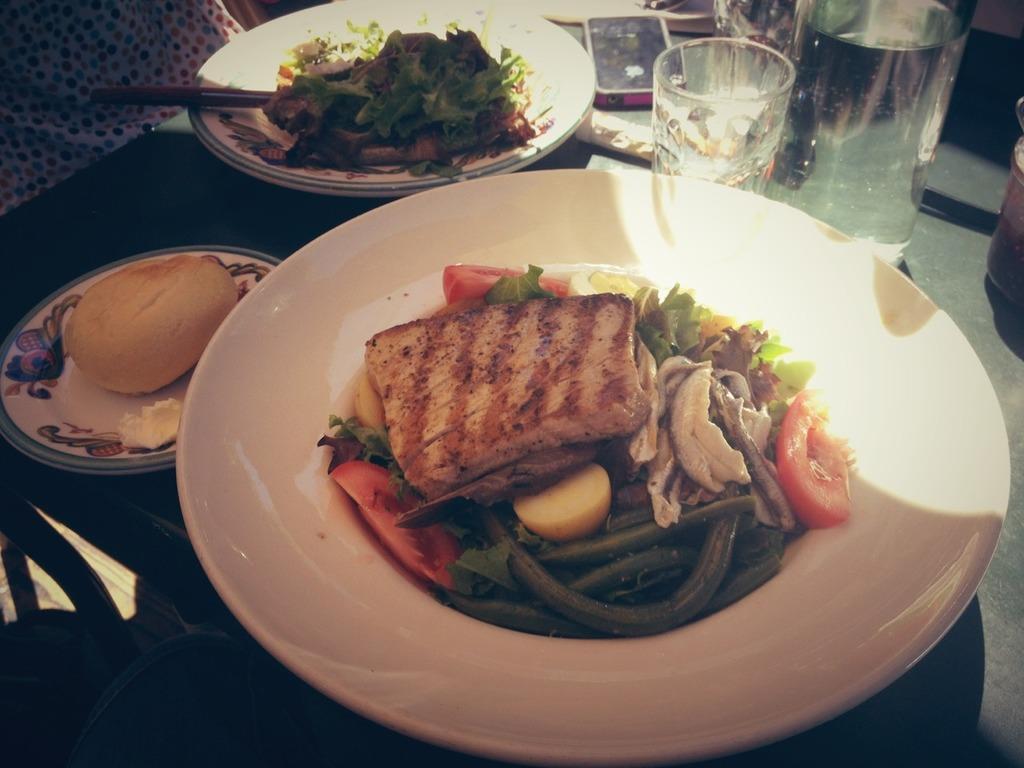Describe this image in one or two sentences. In this image I can see three plates and on it can see different types of food. On the top right side of this image I can see a bottle, a glass and a cell phone. I can also see water in the bottle and on the top left corner of this image I can see a white colour thing and on it I can see number of dots. 